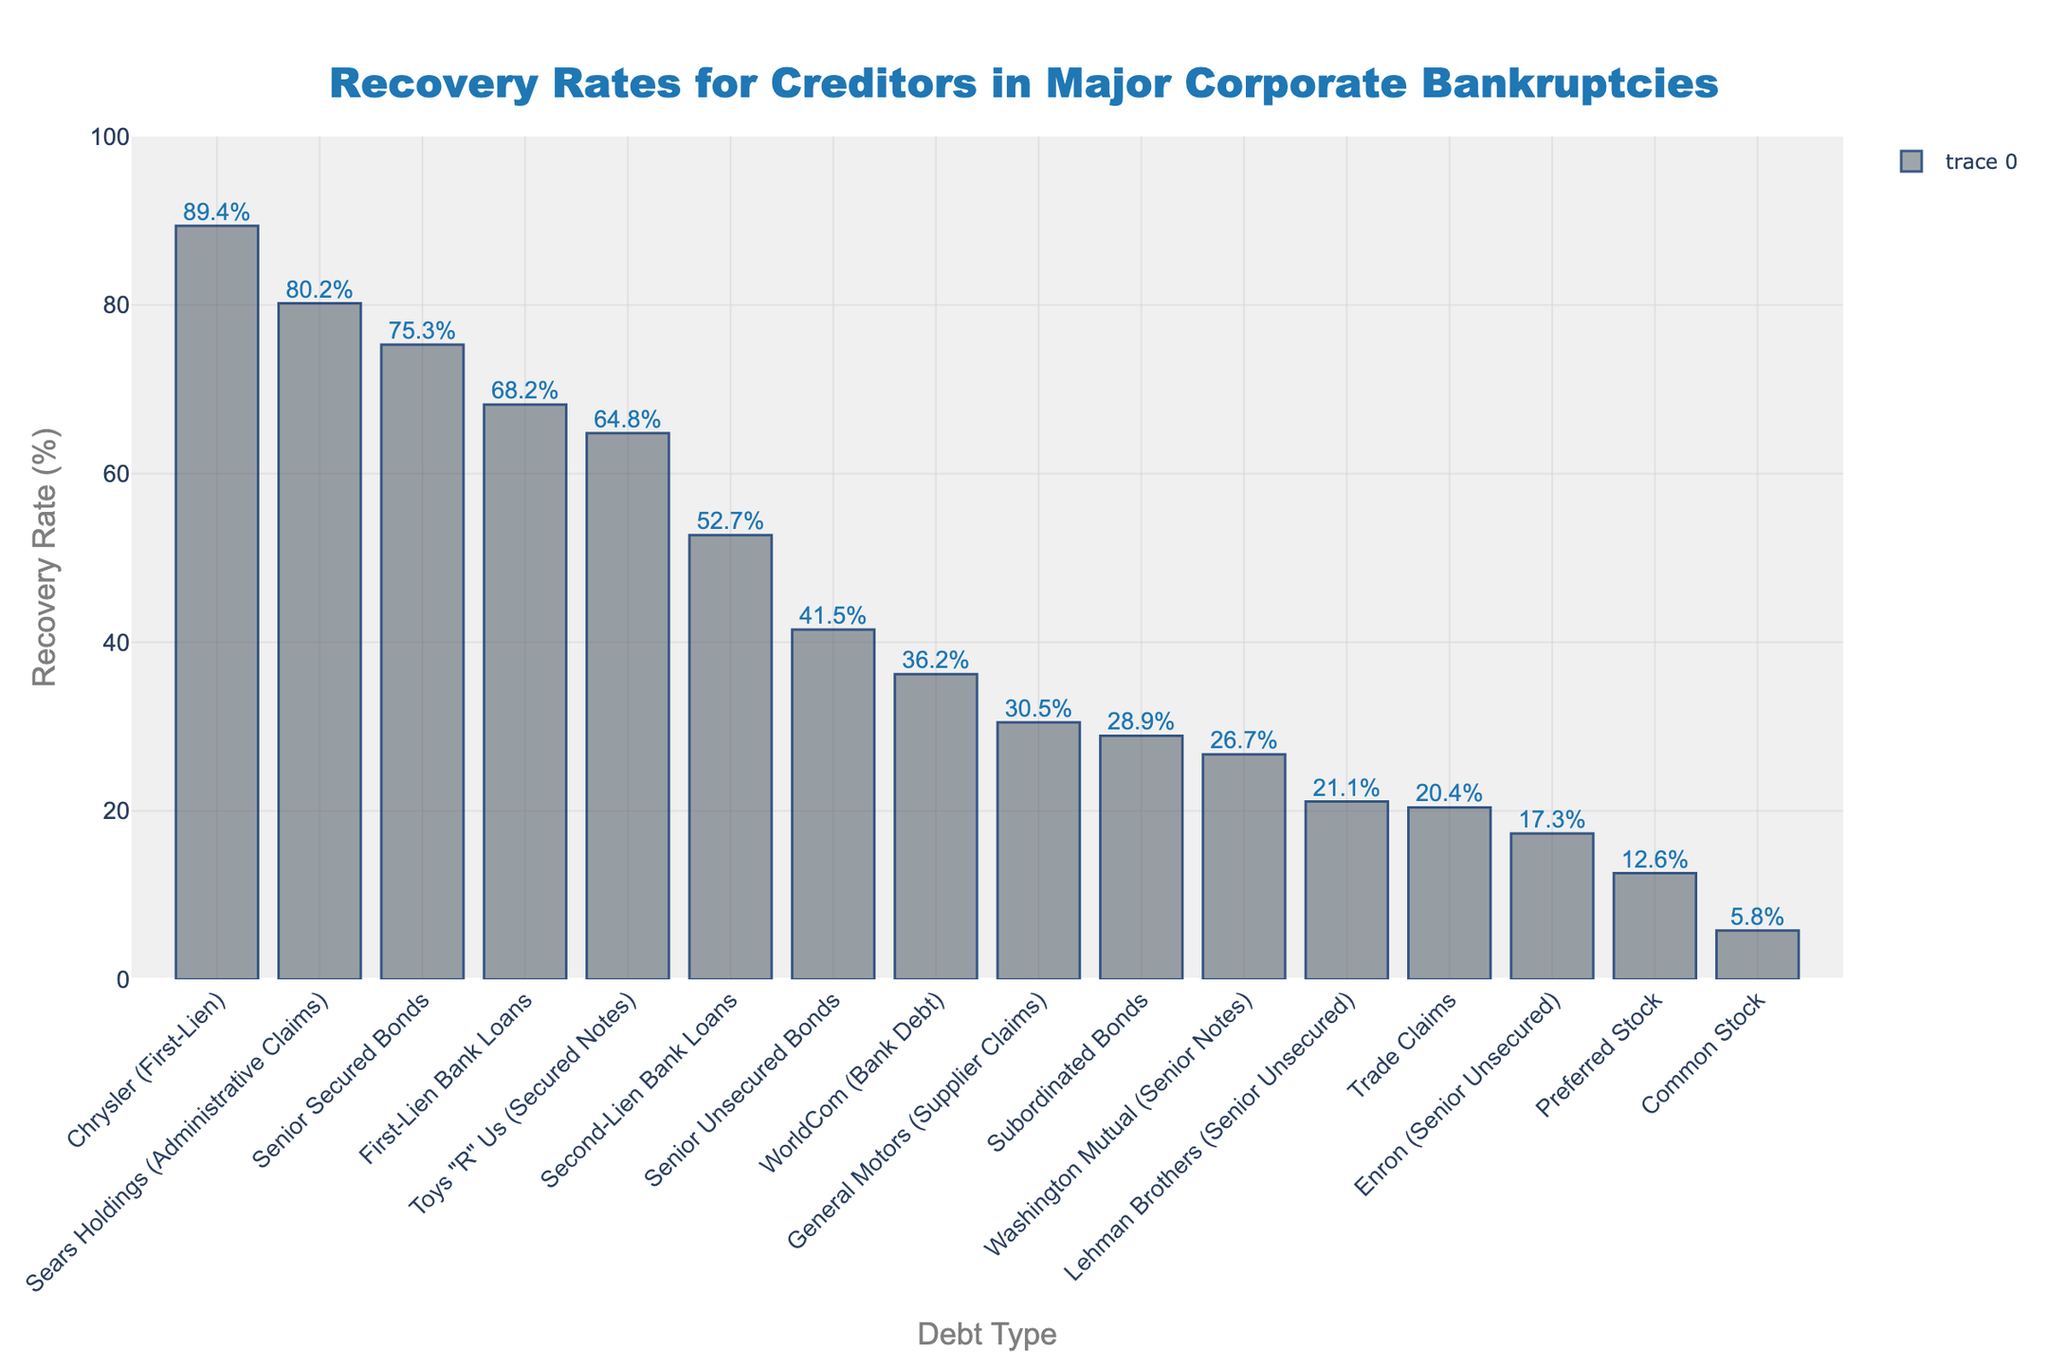Which debt type has the highest recovery rate? The highest bar in the chart represents the debt type with the highest recovery rate. According to the chart, "Chrysler (First-Lien)" has the highest recovery rate of 89.4%.
Answer: Chrysler (First-Lien) Which debt type has the lowest recovery rate? The lowest bar in the chart represents the debt type with the lowest recovery rate. According to the chart, "Common Stock" has the lowest recovery rate of 5.8%.
Answer: Common Stock What is the difference in recovery rates between "Senior Secured Bonds" and "Senior Unsecured Bonds"? The recovery rate for "Senior Secured Bonds" is 75.3% and for "Senior Unsecured Bonds" is 41.5%. The difference is 75.3% - 41.5% = 33.8%.
Answer: 33.8% What is the average recovery rate for "Senior Secured Bonds" and "First-Lien Bank Loans"? The recovery rates are 75.3% for "Senior Secured Bonds" and 68.2% for "First-Lien Bank Loans". The average is (75.3 + 68.2) / 2 = 71.75%.
Answer: 71.75% Which company has a higher recovery rate for "Senior Unsecured" debt, Lehman Brothers or Enron? According to the chart, "Lehman Brothers (Senior Unsecured)" has a recovery rate of 21.1% and "Enron (Senior Unsecured)" has a recovery rate of 17.3%. Lehman Brothers has a higher recovery rate.
Answer: Lehman Brothers What is the sum of recovery rates for "Trade Claims" and "Preferred Stock"? The recovery rate for "Trade Claims" is 20.4% and for "Preferred Stock" is 12.6%. The sum is 20.4% + 12.6% = 33%.
Answer: 33% Rank the recovery rates of "Senior Secured Bonds", "First-Lien Bank Loans", and "Second-Lien Bank Loans" from highest to lowest. According to the chart:
1. "Senior Secured Bonds" at 75.3%
2. "First-Lien Bank Loans" at 68.2%
3. "Second-Lien Bank Loans" at 52.7%.
Answer: Senior Secured Bonds > First-Lien Bank Loans > Second-Lien Bank Loans What is the median recovery rate of all the debt types listed in the chart? To calculate the median, list all the recovery rates in ascending order: 5.8, 12.6, 17.3, 20.4, 21.1, 26.7, 28.9, 30.5, 36.2, 41.5, 52.7, 64.8, 68.2, 75.3, 80.2, 89.4. With 16 values, the median is the average of the 8th and 9th values: (30.5 + 36.2) / 2 = 33.35%.
Answer: 33.35% Which is taller, the bar representing "Sears Holdings (Administrative Claims)" or the bar representing "Toys 'R' Us (Secured Notes)"? According to the chart, "Sears Holdings (Administrative Claims)" has a recovery rate of 80.2% and "Toys 'R' Us (Secured Notes)" has a recovery rate of 64.8%. "Sears Holdings (Administrative Claims)" is taller.
Answer: Sears Holdings (Administrative Claims) What is the range of recovery rates shown in the chart? The range is calculated as the difference between the highest and the lowest recovery rates. The highest is "Chrysler (First-Lien)" at 89.4% and the lowest is "Common Stock" at 5.8%. The range is 89.4% - 5.8% = 83.6%.
Answer: 83.6% 